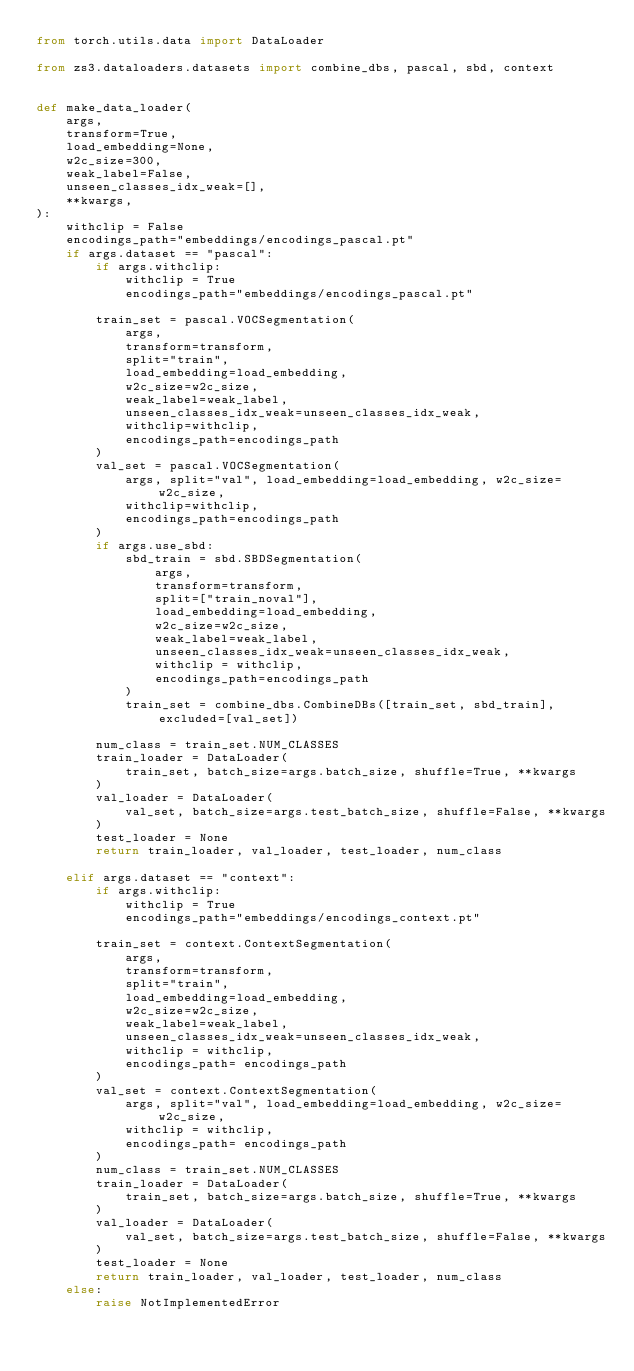Convert code to text. <code><loc_0><loc_0><loc_500><loc_500><_Python_>from torch.utils.data import DataLoader

from zs3.dataloaders.datasets import combine_dbs, pascal, sbd, context


def make_data_loader(
    args,
    transform=True,
    load_embedding=None,
    w2c_size=300,
    weak_label=False,
    unseen_classes_idx_weak=[],
    **kwargs,
):
    withclip = False
    encodings_path="embeddings/encodings_pascal.pt"
    if args.dataset == "pascal":
        if args.withclip:
            withclip = True
            encodings_path="embeddings/encodings_pascal.pt"

        train_set = pascal.VOCSegmentation(
            args,
            transform=transform,
            split="train",
            load_embedding=load_embedding,
            w2c_size=w2c_size,
            weak_label=weak_label,
            unseen_classes_idx_weak=unseen_classes_idx_weak,
            withclip=withclip,
            encodings_path=encodings_path
        )
        val_set = pascal.VOCSegmentation(
            args, split="val", load_embedding=load_embedding, w2c_size=w2c_size,
            withclip=withclip,
            encodings_path=encodings_path
        )
        if args.use_sbd:
            sbd_train = sbd.SBDSegmentation(
                args,
                transform=transform,
                split=["train_noval"],
                load_embedding=load_embedding,
                w2c_size=w2c_size,
                weak_label=weak_label,
                unseen_classes_idx_weak=unseen_classes_idx_weak,
                withclip = withclip,
                encodings_path=encodings_path
            )
            train_set = combine_dbs.CombineDBs([train_set, sbd_train], excluded=[val_set])

        num_class = train_set.NUM_CLASSES
        train_loader = DataLoader(
            train_set, batch_size=args.batch_size, shuffle=True, **kwargs
        )
        val_loader = DataLoader(
            val_set, batch_size=args.test_batch_size, shuffle=False, **kwargs
        )
        test_loader = None
        return train_loader, val_loader, test_loader, num_class

    elif args.dataset == "context":
        if args.withclip:
            withclip = True
            encodings_path="embeddings/encodings_context.pt"

        train_set = context.ContextSegmentation(
            args,
            transform=transform,
            split="train",
            load_embedding=load_embedding,
            w2c_size=w2c_size,
            weak_label=weak_label,
            unseen_classes_idx_weak=unseen_classes_idx_weak,
            withclip = withclip,
            encodings_path= encodings_path
        )
        val_set = context.ContextSegmentation(
            args, split="val", load_embedding=load_embedding, w2c_size=w2c_size, 
            withclip = withclip,
            encodings_path= encodings_path
        )
        num_class = train_set.NUM_CLASSES
        train_loader = DataLoader(
            train_set, batch_size=args.batch_size, shuffle=True, **kwargs
        )
        val_loader = DataLoader(
            val_set, batch_size=args.test_batch_size, shuffle=False, **kwargs
        )
        test_loader = None
        return train_loader, val_loader, test_loader, num_class
    else:
        raise NotImplementedError
</code> 